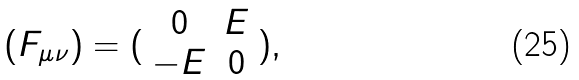Convert formula to latex. <formula><loc_0><loc_0><loc_500><loc_500>( F _ { \mu \nu } ) = ( \begin{array} { c c } 0 & E \\ - E & 0 \end{array} ) ,</formula> 